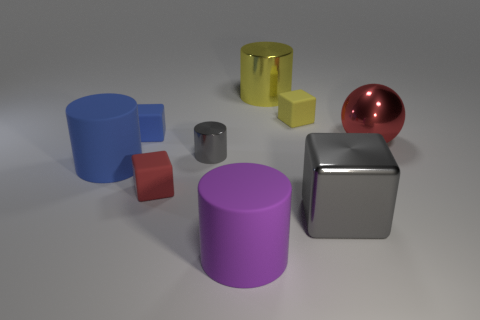Is there any other thing that has the same color as the large metal cylinder?
Give a very brief answer. Yes. What is the color of the rubber thing on the right side of the metal thing behind the red metallic object?
Offer a very short reply. Yellow. What material is the large cylinder that is on the right side of the large rubber cylinder to the right of the small rubber cube in front of the small gray metallic object?
Keep it short and to the point. Metal. How many other yellow matte cubes are the same size as the yellow rubber cube?
Make the answer very short. 0. The cylinder that is behind the large blue thing and in front of the yellow metal thing is made of what material?
Make the answer very short. Metal. There is a blue matte cube; what number of big red objects are left of it?
Offer a very short reply. 0. There is a big gray shiny thing; is it the same shape as the big rubber object left of the tiny red block?
Your answer should be very brief. No. Is there another small yellow matte thing that has the same shape as the small yellow object?
Make the answer very short. No. What shape is the tiny thing on the right side of the cylinder in front of the large gray cube?
Make the answer very short. Cube. There is a small thing that is on the right side of the tiny metallic cylinder; what is its shape?
Your answer should be very brief. Cube. 